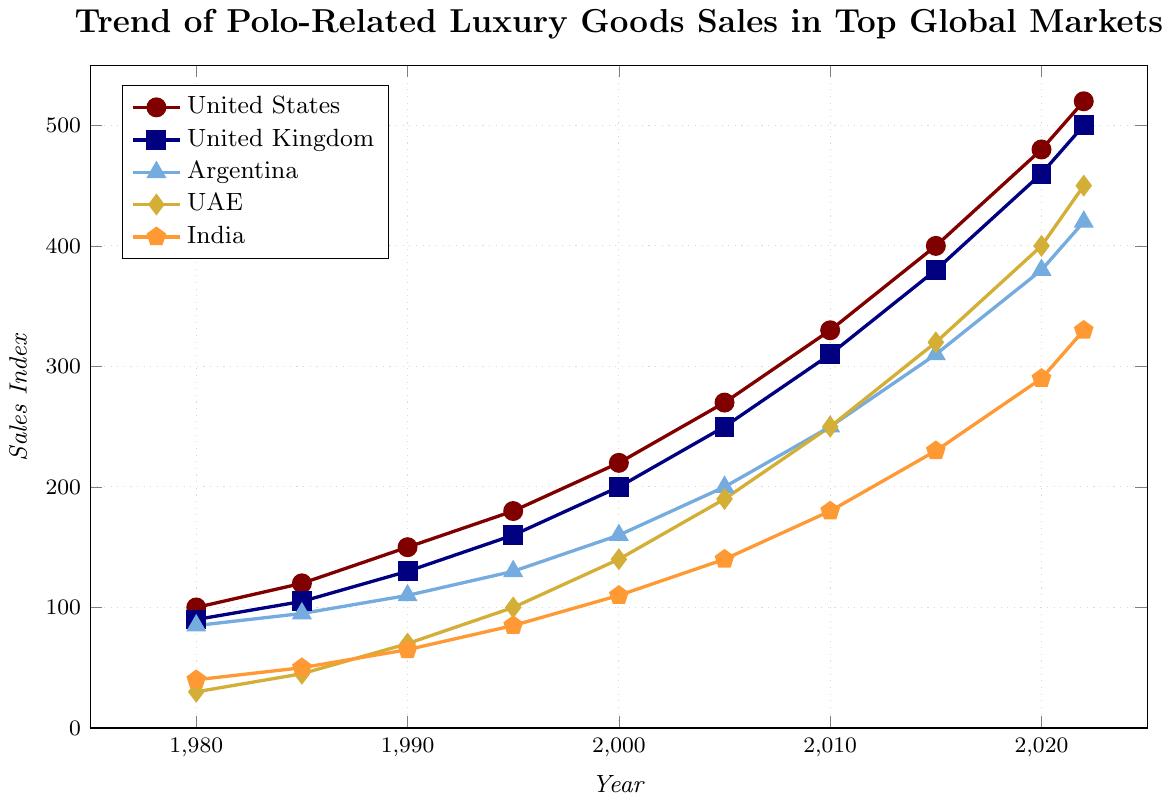How does the sales index trend in the United States compare with that of the United Kingdom from 1980 to 2022? Both the United States and the United Kingdom show a consistent upward trend in sales index from 1980 to 2022. However, the United States starts at 100 in 1980 and ends at 520 in 2022, while the United Kingdom starts at 90 and ends at 500. This means the United States has a slightly higher overall increase.
Answer: The United States has a slightly higher overall increase Which country shows the highest sales index in 2022 and what is the value? By looking at the endpoints of all the lines in 2022, the United States shows the highest sales index value, which is 520.
Answer: The United States, 520 How much did India's sales index increase from 1980 to 2022? India's sales index is 40 in 1980 and 330 in 2022. The increase can be calculated as 330 - 40 = 290.
Answer: 290 Which country had the least growth in sales index from 1980 to 2022? To find the country with the least growth, we calculate the difference in values for all countries from 1980 to 2022. The differences are:
- United States: 520 - 100 = 420
- United Kingdom: 500 - 90 = 410
- Argentina: 420 - 85 = 335
- UAE: 450 - 30 = 420
- India: 330 - 40 = 290
India has the least growth: 290.
Answer: India Between which two consecutive periods did the United Arab Emirates see the highest increase in sales index? Checking the UAE's values for consecutive periods:
- 1980 to 1985: 15
- 1985 to 1990: 25
- 1990 to 1995: 30
- 1995 to 2000: 40
- 2000 to 2005: 50
- 2005 to 2010: 60
- 2010 to 2015: 70
- 2015 to 2020: 80
- 2020 to 2022: 50
The highest increase occurred between 2015 to 2020, which is 80.
Answer: 2015 to 2020 Compare the slope of the lines for the United States and UAE in the period 2005 to 2010. Which country saw a steeper increase? For the United States: 
- From 270 in 2005 to 330 in 2010, the increase is 60. 
For UAE: 
- From 190 in 2005 to 250 in 2010, the increase is 60. 
Both the United States and UAE saw the same increase. The slopes are equal.
Answer: Equal slopes What is the average sales index of Argentina over the given years? The values for Argentina are: 85, 95, 110, 130, 160, 200, 250, 310, 380, 420.
Sum these values: 85 + 95 + 110 + 130 + 160 + 200 + 250 + 310 + 380 + 420 = 2140.
Divide by the number of years (10): 2140 / 10 = 214.
Answer: 214 In which decade did the sales index for India surpass 100? Checking the values for India over the decades:
- 1980: 40
- 1985: 50
- 1990: 65
- 1995: 85
- 2000: 110
India surpasses 100 in the year 2000.
Answer: 2000 What is the total increase in sales index for all countries from 1980 to 2022 combined? Calculate the increase for each country and sum them:
- United States: 520 - 100 = 420
- United Kingdom: 500 - 90 = 410
- Argentina: 420 - 85 = 335
- UAE: 450 - 30 = 420
- India: 330 - 40 = 290
Total increase: 420 + 410 + 335 + 420 + 290 = 1875
Answer: 1875 Which country had the slowest growth rate in the 1990s? Determine the growth for each country from 1990 to 2000:
- United States: 220 - 150 = 70
- United Kingdom: 200 - 130 = 70
- Argentina: 160 - 110 = 50
- UAE: 140 - 70 = 70
- India: 110 - 65 = 45
India had the slowest growth rate in the 1990s with an increase of 45.
Answer: India 